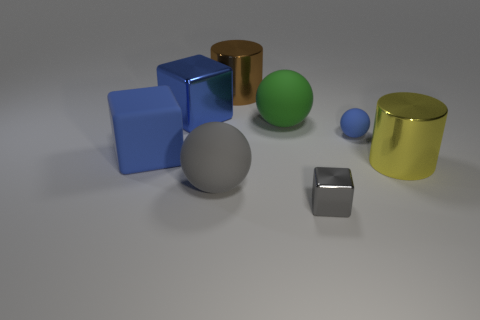Subtract all blue cubes. How many were subtracted if there are1blue cubes left? 1 Add 2 big blue matte blocks. How many objects exist? 10 Subtract all cylinders. How many objects are left? 6 Add 6 large green things. How many large green things exist? 7 Subtract 0 purple spheres. How many objects are left? 8 Subtract all gray rubber spheres. Subtract all green things. How many objects are left? 6 Add 7 tiny blue objects. How many tiny blue objects are left? 8 